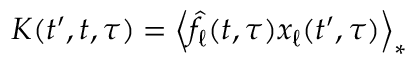Convert formula to latex. <formula><loc_0><loc_0><loc_500><loc_500>K ( t ^ { \prime } , t , \tau ) = \left \langle \hat { f } _ { \ell } ( t , \tau ) x _ { \ell } ( t ^ { \prime } , \tau ) \right \rangle _ { * }</formula> 